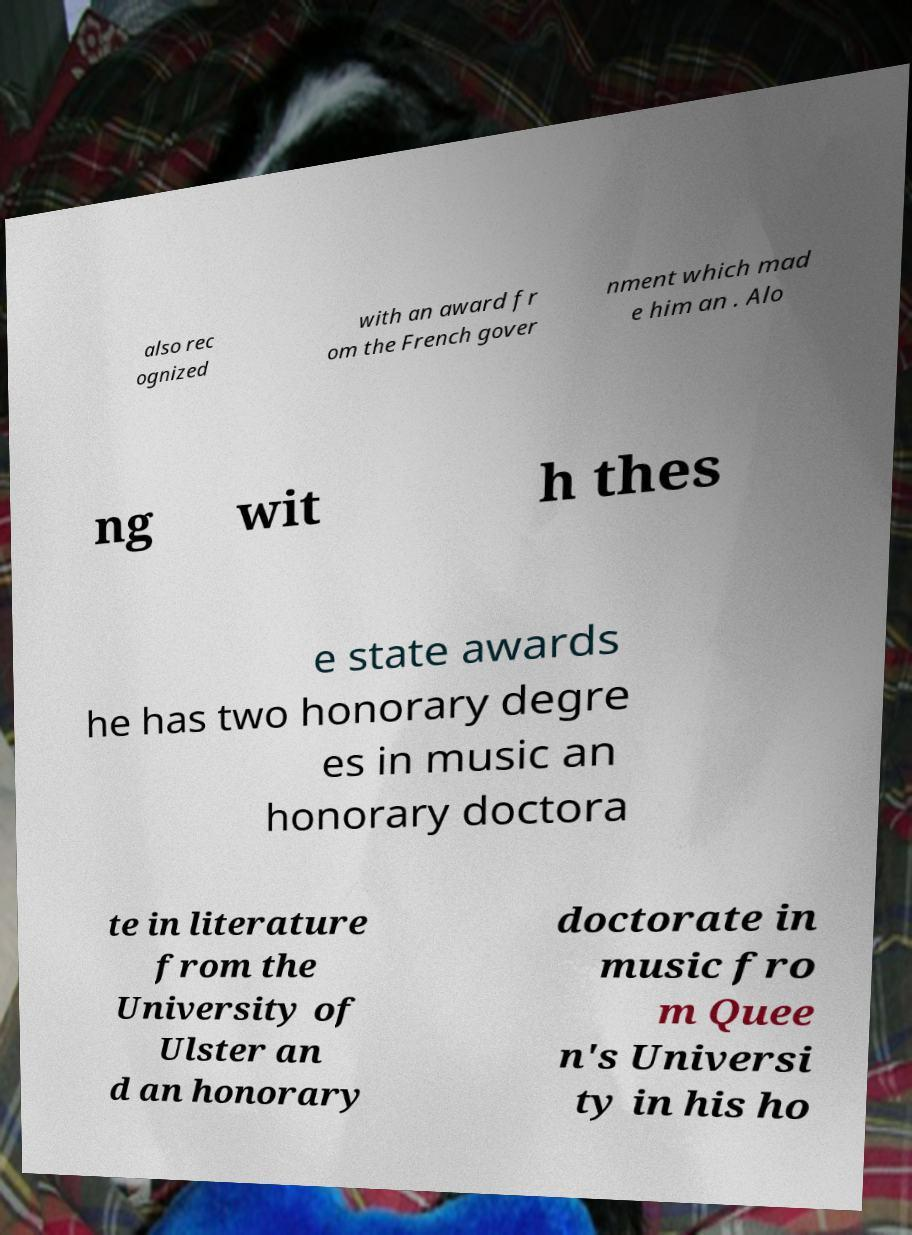I need the written content from this picture converted into text. Can you do that? also rec ognized with an award fr om the French gover nment which mad e him an . Alo ng wit h thes e state awards he has two honorary degre es in music an honorary doctora te in literature from the University of Ulster an d an honorary doctorate in music fro m Quee n's Universi ty in his ho 